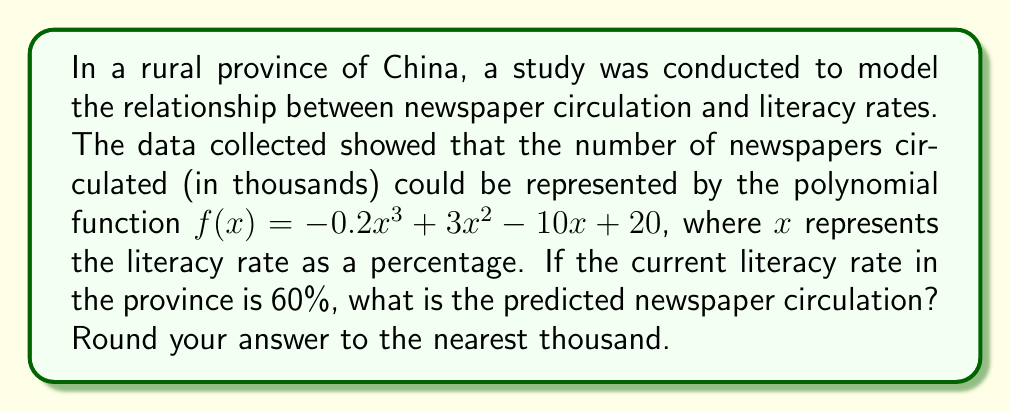Could you help me with this problem? To solve this problem, we need to follow these steps:

1. Identify the given function and variable:
   $f(x) = -0.2x^3 + 3x^2 - 10x + 20$
   where $x$ is the literacy rate percentage

2. Substitute the given literacy rate (60%) into the function:
   $f(60) = -0.2(60)^3 + 3(60)^2 - 10(60) + 20$

3. Calculate each term:
   $-0.2(60)^3 = -0.2 \times 216000 = -43200$
   $3(60)^2 = 3 \times 3600 = 10800$
   $-10(60) = -600$
   $20$ remains as is

4. Sum up all the terms:
   $f(60) = -43200 + 10800 - 600 + 20 = -32980$

5. The result is negative, which doesn't make sense for circulation numbers. This indicates that the model predicts no circulation at this literacy rate. Therefore, we round to the nearest thousand, which is 0.
Answer: 0 thousand newspapers 